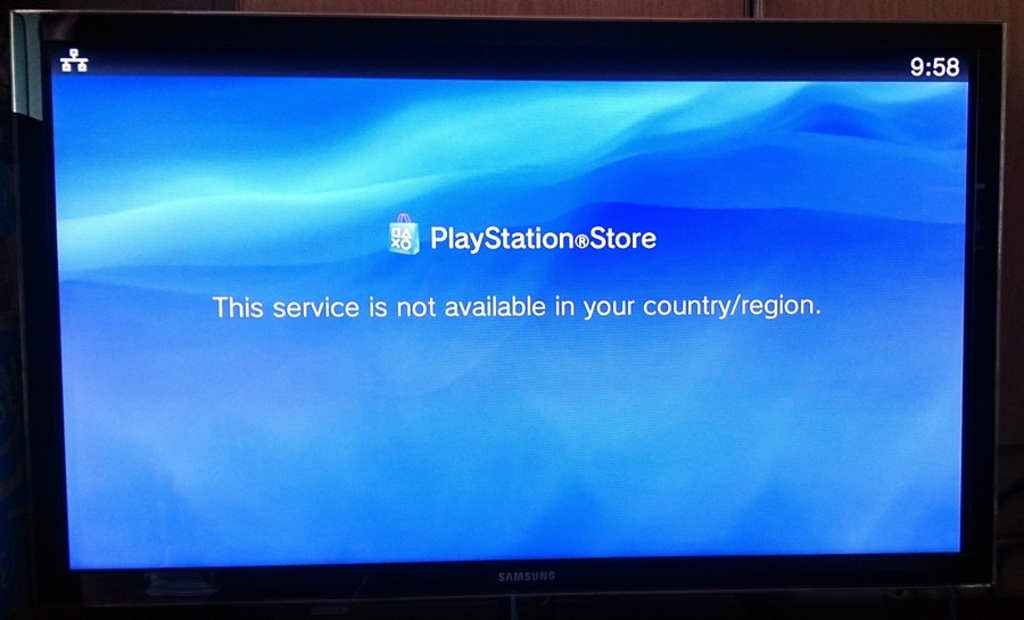What's happening in the scene? The image captures a moment of frustration for a gamer. The television screen, awash in a soothing gradient of blue, displays an error message from the PlayStation Store. The message, stark and clear, states: "This service is not available in your country/region." It's a reminder of the digital boundaries that still exist in our increasingly connected world. The time on the screen reads 9:58, perhaps indicating a late-night gaming session interrupted. The gamer's anticipation of a new game or an update to an existing one is met with disappointment, as the PlayStation Store remains inaccessible in their location. 